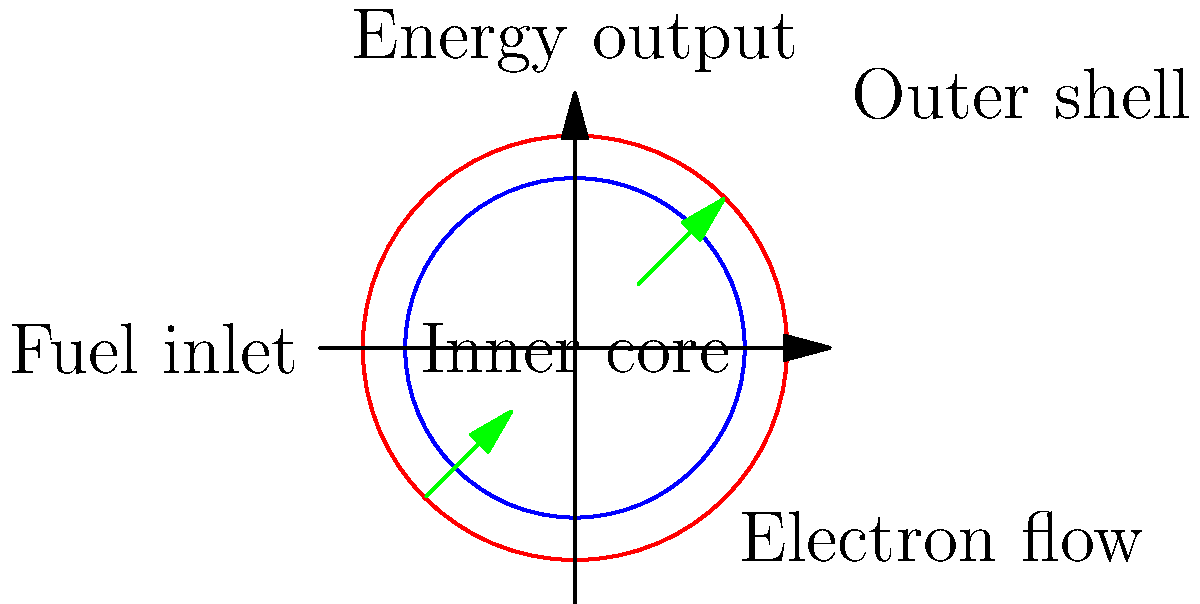In this hypothetical cold fusion reactor diagram, what is the primary function of the inner core in relation to the outer shell? To understand the function of the inner core in relation to the outer shell in this hypothetical cold fusion reactor, let's analyze the diagram step-by-step:

1. Structure: The diagram shows two concentric circles - a red outer circle (outer shell) and a blue inner circle (inner core).

2. Fuel inlet: There's an arrow pointing inward on the left side, labeled "Fuel inlet". This suggests that the fuel enters the reactor through this point.

3. Energy output: An upward arrow at the top is labeled "Energy output", indicating that this is where the energy produced by the reactor is extracted.

4. Electron flow: Green arrows show electron movement from the bottom-left to the top-right, passing through both the inner core and outer shell.

5. Relationship between core and shell: The electron flow passes through both components, suggesting that both play a role in the fusion process.

Given this information, we can deduce that the primary function of the inner core in relation to the outer shell is to facilitate the fusion reaction:

- The inner core likely contains the fuel and provides the environment for fusion to occur.
- The outer shell probably acts as a containment and heat transfer medium.
- The electron flow between the two components suggests that the inner core initiates the fusion process, while the outer shell helps sustain it and transfer the energy produced.

In cold fusion theory, the reactor would aim to achieve fusion at relatively low temperatures. The inner core might use special materials or structures to catalyze the fusion process, while the outer shell could help maintain the necessary conditions and extract the energy produced.
Answer: Facilitate fusion reaction 